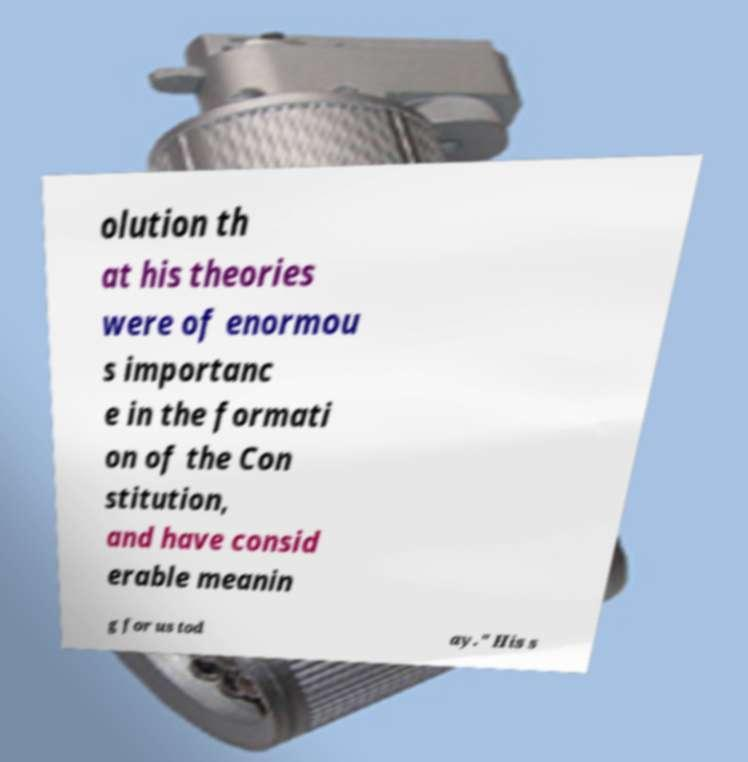Please read and relay the text visible in this image. What does it say? olution th at his theories were of enormou s importanc e in the formati on of the Con stitution, and have consid erable meanin g for us tod ay." His s 